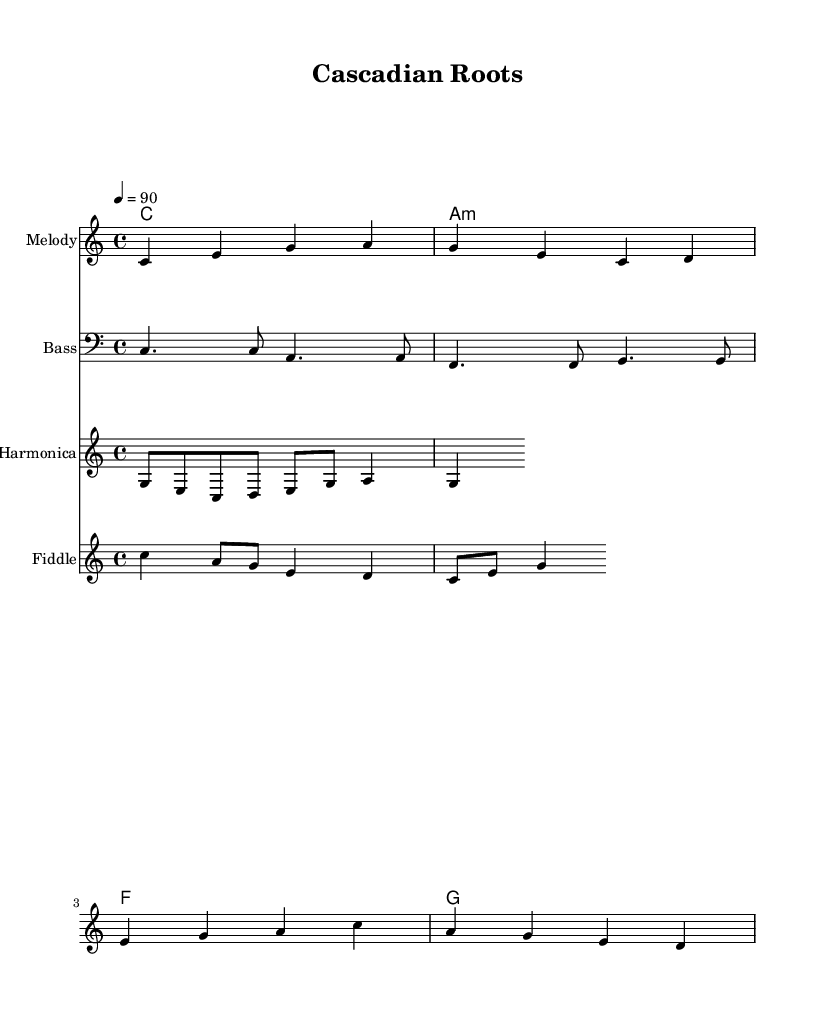What is the key signature of this music? The key signature indicated in the music is C major, as there are no sharps or flats shown at the beginning of the score.
Answer: C major What is the time signature of the piece? The time signature is found at the beginning of the score, which indicates that it is in 4/4 time, meaning there are four beats per measure.
Answer: 4/4 What is the tempo marking? The tempo marking is indicated alongside the time signature, which shows a speed of 90 beats per minute.
Answer: 90 How many measures are in the melody? By counting the measures in the melody staff, there are a total of four measures present in the melody section.
Answer: 4 Which instrument plays the bass line? The staff labeled "Bass" specifically indicates that the bass line is played by the bass instrument.
Answer: Bass What chord follows the A minor chord in the chord progression? From the chord progression provided in the chordNames section, after the A minor chord, the next chord is F major.
Answer: F Which folk instrument is used in this reggae-fusion composition? The staff labeled "Fiddle" indicates that this is a folk instrument incorporated into the reggae-fusion tracks.
Answer: Fiddle 